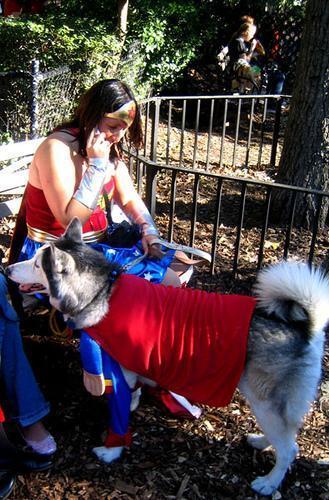How many people are there?
Give a very brief answer. 2. How many people can you see?
Give a very brief answer. 2. How many birds can be seen?
Give a very brief answer. 0. 